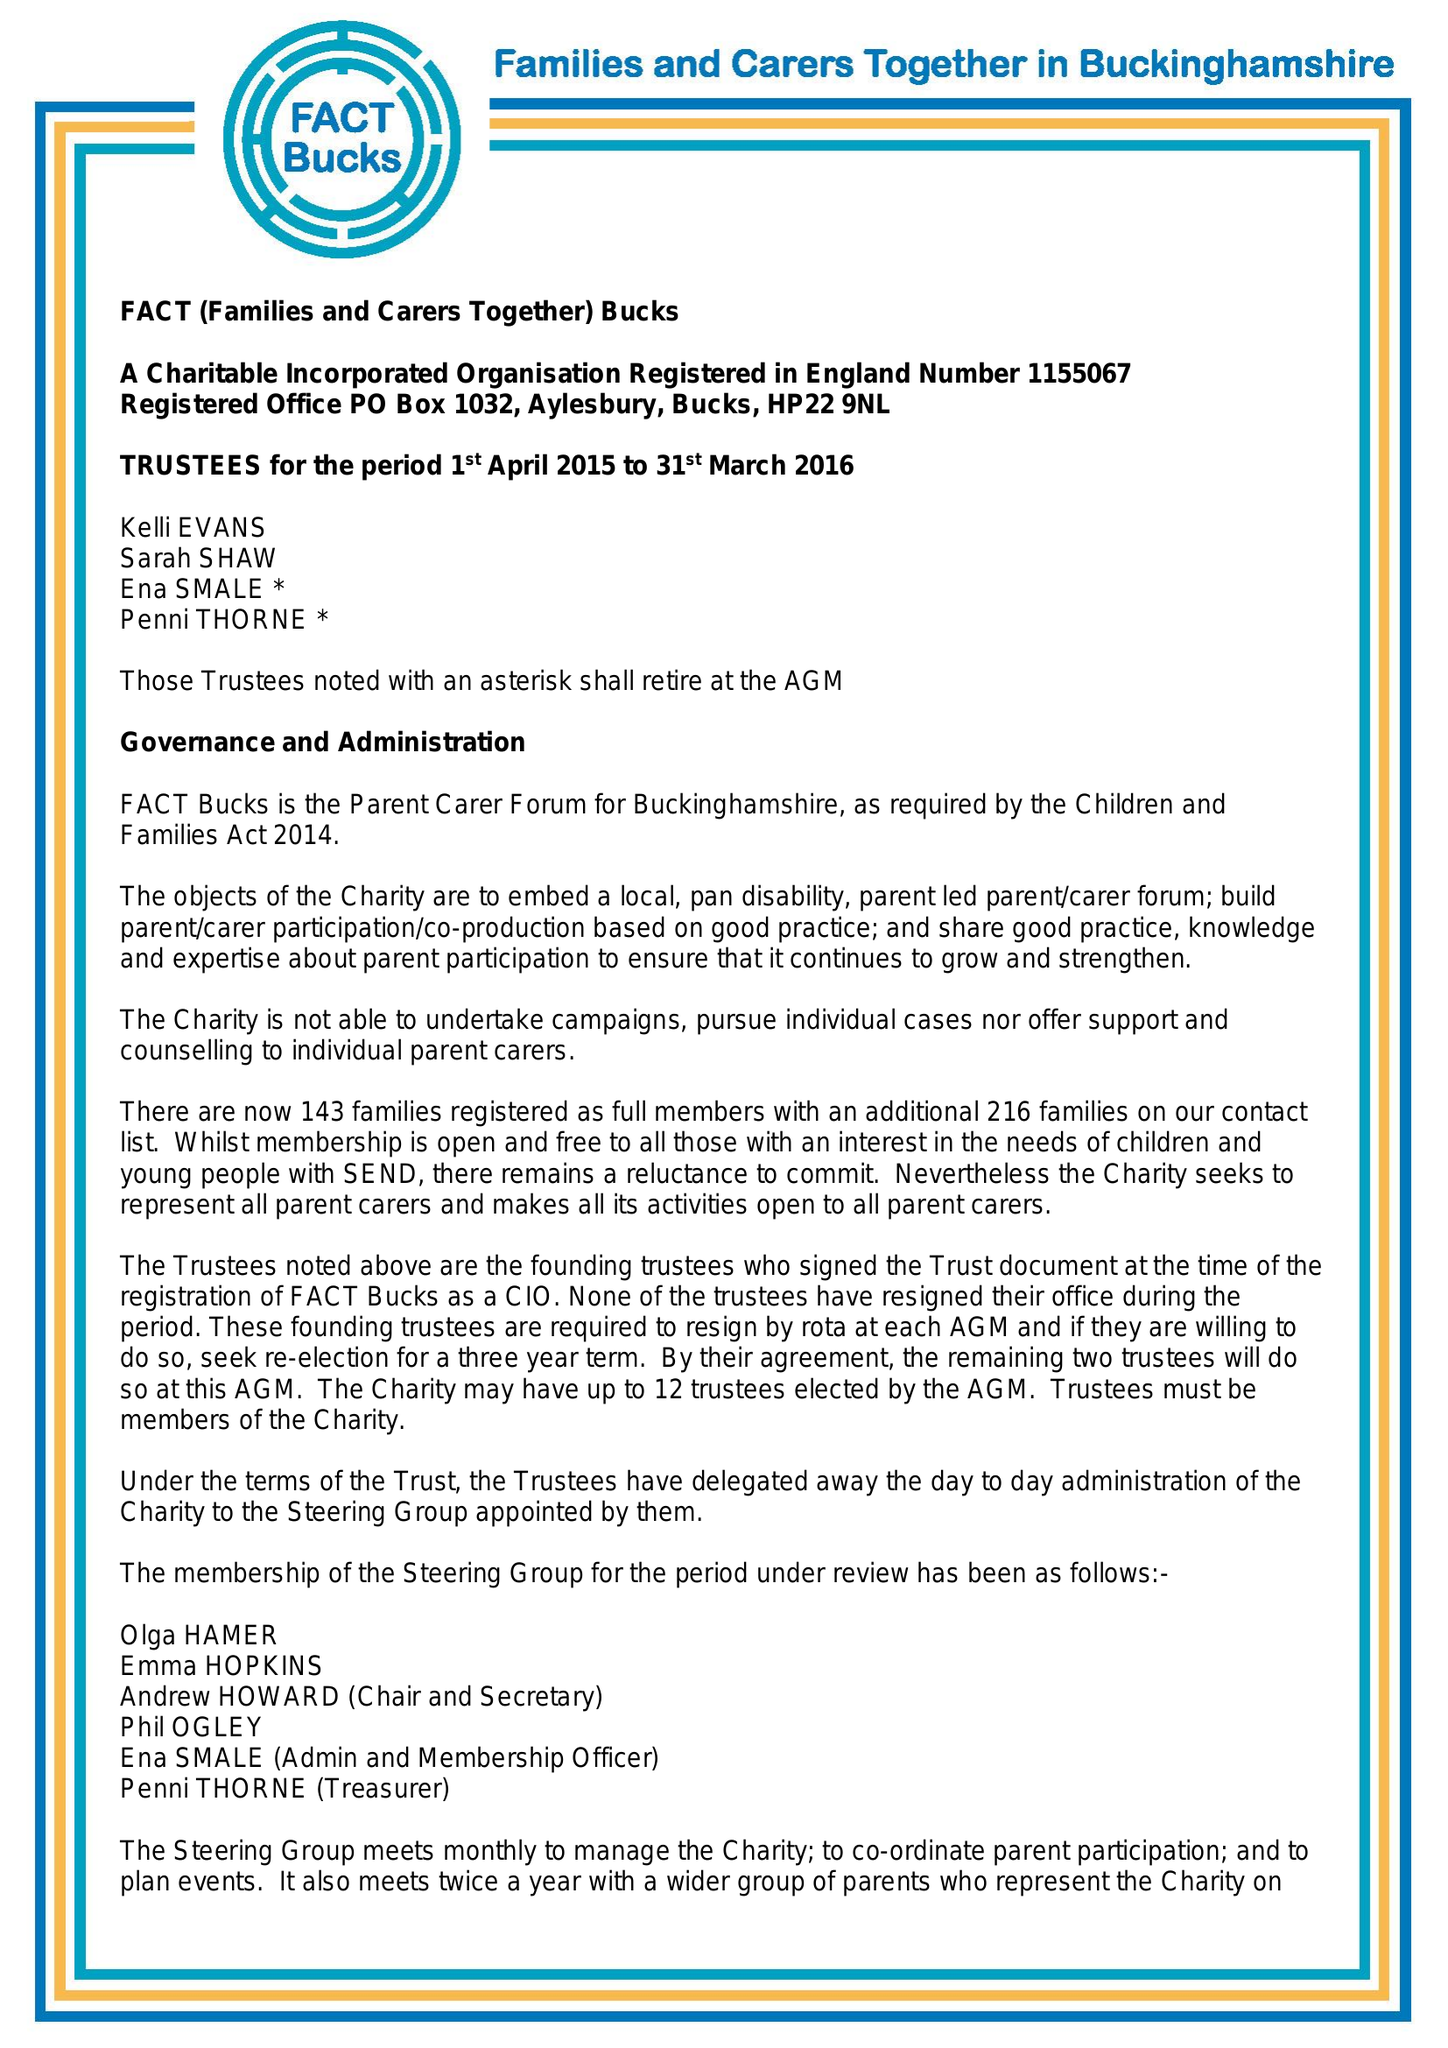What is the value for the report_date?
Answer the question using a single word or phrase. 2016-03-31 